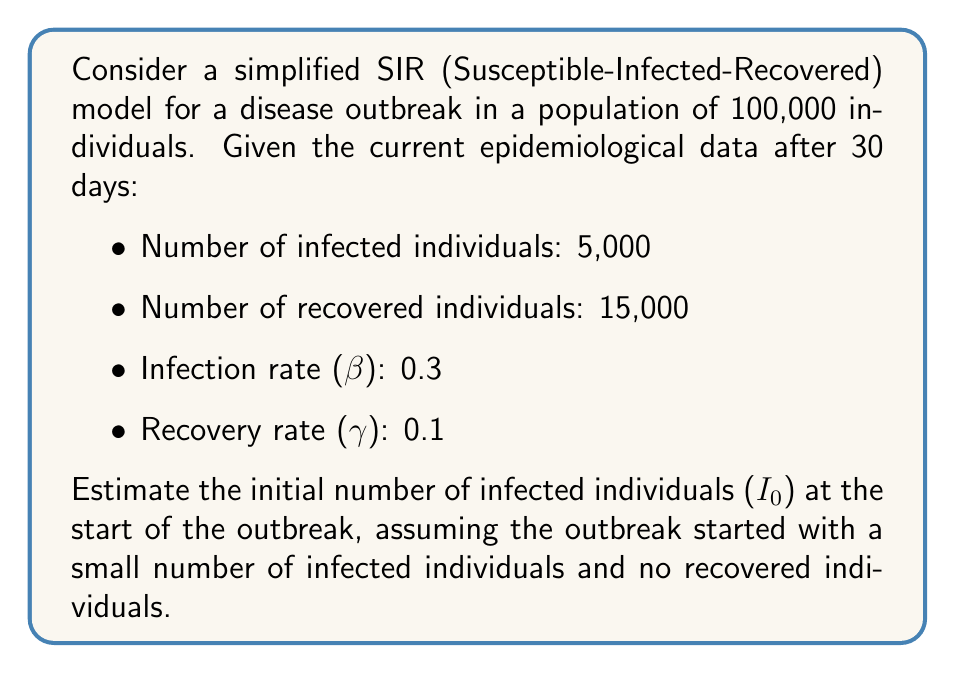Help me with this question. To estimate the initial number of infected individuals, we'll use the SIR model equations and work backwards from the current data:

1) The SIR model is described by the following differential equations:

   $$\frac{dS}{dt} = -\beta SI$$
   $$\frac{dI}{dt} = \beta SI - \gamma I$$
   $$\frac{dR}{dt} = \gamma I$$

2) We know that after 30 days:
   - S(30) = 80,000 (Susceptible)
   - I(30) = 5,000 (Infected)
   - R(30) = 15,000 (Recovered)

3) We can use the equation for $\frac{dR}{dt}$ to estimate the average number of infected individuals over the 30-day period:

   $$R(30) - R(0) = \gamma \int_0^{30} I(t) dt$$

4) Assuming R(0) = 0, we have:

   $$15,000 = 0.1 \cdot 30 \cdot \bar{I}$$

   where $\bar{I}$ is the average number of infected individuals over the 30-day period.

5) Solving for $\bar{I}$:

   $$\bar{I} = \frac{15,000}{0.1 \cdot 30} = 5,000$$

6) Now, we can use the logistic growth model to estimate I₀:

   $$I(t) = \frac{K I_0 e^{rt}}{K + I_0(e^{rt} - 1)}$$

   where K is the carrying capacity (total population), r is the growth rate (β - γ), and t is time.

7) We can approximate I(30) ≈ $\bar{I}$ = 5,000, and solve for I₀:

   $$5,000 = \frac{100,000 \cdot I_0 \cdot e^{(0.3-0.1) \cdot 30}}{100,000 + I_0(e^{(0.3-0.1) \cdot 30} - 1)}$$

8) Solving this equation numerically (using a computer or calculator), we find:

   I₀ ≈ 10
Answer: 10 infected individuals 